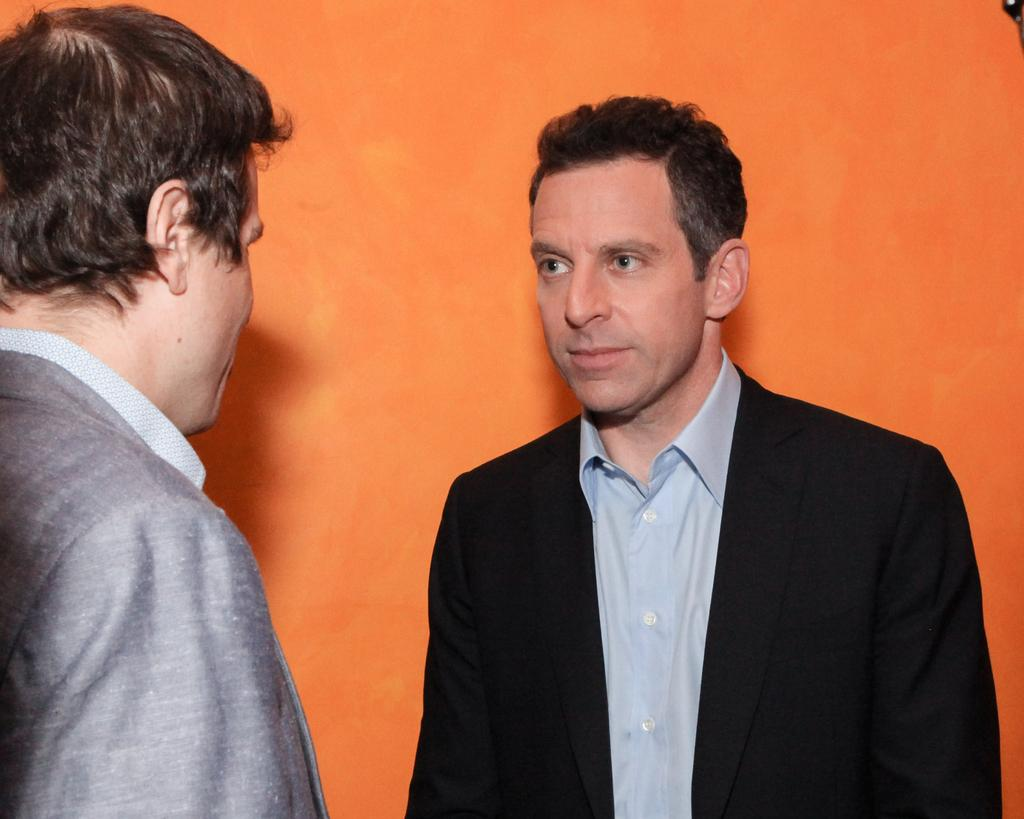Who is the main subject in the image? There is a man in the middle of the image. What is the man wearing? The man is wearing a suit and a shirt. What can be observed about the background of the image? The background of the image is orange in color. Are there any other people in the image? Yes, there is another man on the left side of the image. Reasoning: Let' Let's think step by step in order to produce the conversation. We start by identifying the main subject in the image, which is the man in the middle. Then, we describe his attire, focusing on the suit and shirt. Next, we mention the background color, which is orange. Finally, we acknowledge the presence of another man on the left side of the image. Each question is designed to elicit a specific detail about the image that is known from the provided facts. Absurd Question/Answer: What type of dock can be seen in the image? There is no dock present in the image. How many balls are visible in the image? There are no balls visible in the image. What type of scale can be seen in the image? There is no scale present in the image. How many balls are visible in the image? There are no balls visible in the image. 